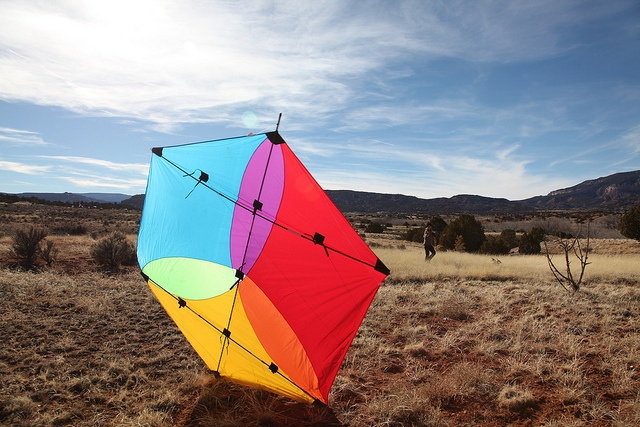Describe the objects in this image and their specific colors. I can see kite in lightgray, red, lightblue, and orange tones and people in lightgray, black, maroon, and gray tones in this image. 